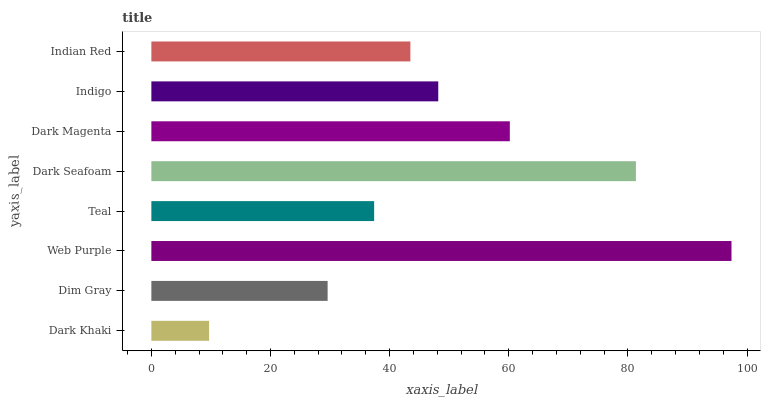Is Dark Khaki the minimum?
Answer yes or no. Yes. Is Web Purple the maximum?
Answer yes or no. Yes. Is Dim Gray the minimum?
Answer yes or no. No. Is Dim Gray the maximum?
Answer yes or no. No. Is Dim Gray greater than Dark Khaki?
Answer yes or no. Yes. Is Dark Khaki less than Dim Gray?
Answer yes or no. Yes. Is Dark Khaki greater than Dim Gray?
Answer yes or no. No. Is Dim Gray less than Dark Khaki?
Answer yes or no. No. Is Indigo the high median?
Answer yes or no. Yes. Is Indian Red the low median?
Answer yes or no. Yes. Is Dark Khaki the high median?
Answer yes or no. No. Is Teal the low median?
Answer yes or no. No. 